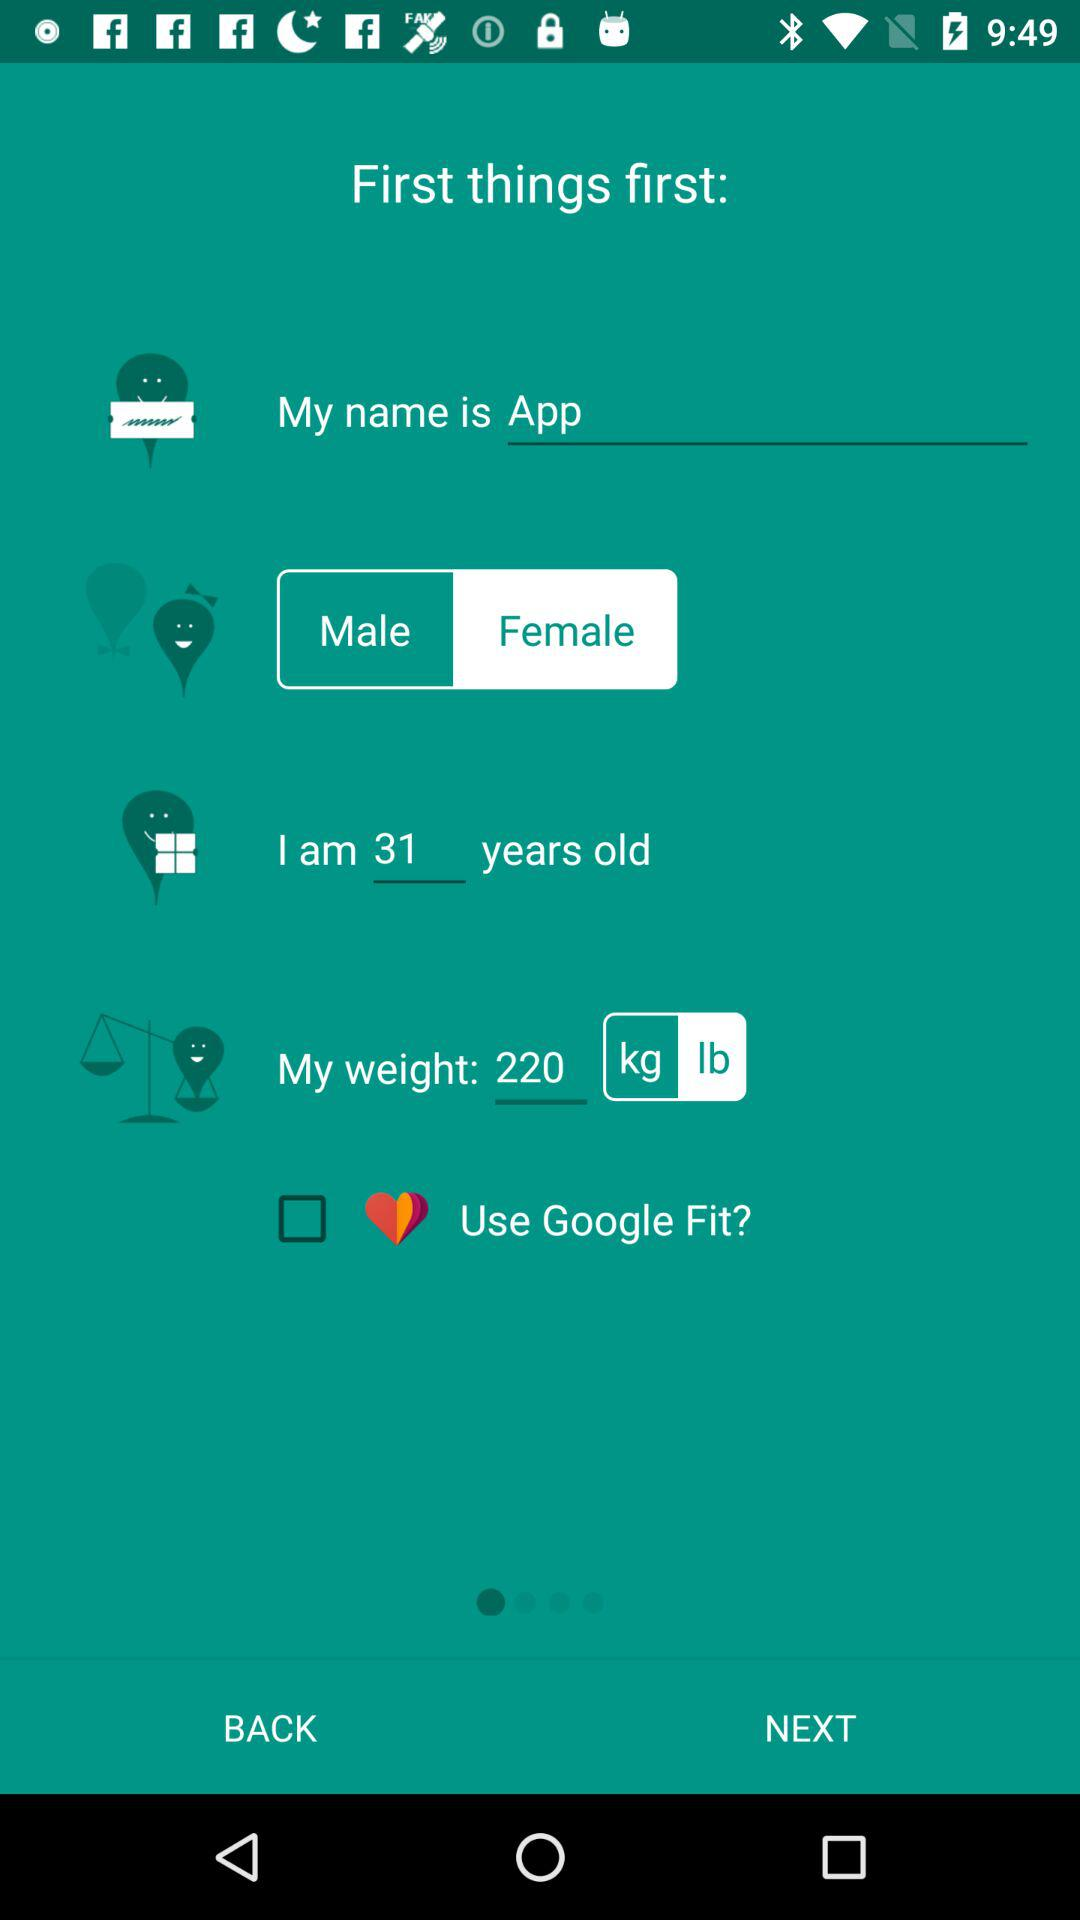What is the age? The age is 31. 